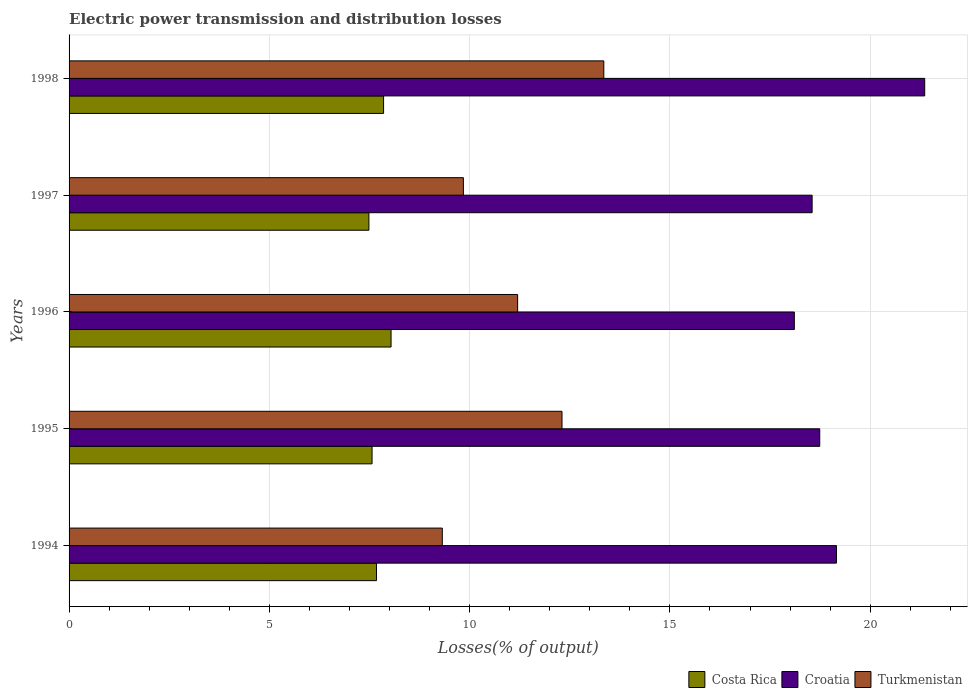How many different coloured bars are there?
Your response must be concise. 3. How many groups of bars are there?
Make the answer very short. 5. How many bars are there on the 4th tick from the top?
Provide a short and direct response. 3. What is the label of the 1st group of bars from the top?
Offer a terse response. 1998. In how many cases, is the number of bars for a given year not equal to the number of legend labels?
Your answer should be very brief. 0. What is the electric power transmission and distribution losses in Turkmenistan in 1995?
Your response must be concise. 12.31. Across all years, what is the maximum electric power transmission and distribution losses in Croatia?
Keep it short and to the point. 21.36. Across all years, what is the minimum electric power transmission and distribution losses in Croatia?
Provide a succinct answer. 18.11. What is the total electric power transmission and distribution losses in Croatia in the graph?
Give a very brief answer. 95.92. What is the difference between the electric power transmission and distribution losses in Croatia in 1994 and that in 1998?
Offer a very short reply. -2.2. What is the difference between the electric power transmission and distribution losses in Turkmenistan in 1994 and the electric power transmission and distribution losses in Croatia in 1996?
Give a very brief answer. -8.79. What is the average electric power transmission and distribution losses in Turkmenistan per year?
Your answer should be very brief. 11.2. In the year 1994, what is the difference between the electric power transmission and distribution losses in Turkmenistan and electric power transmission and distribution losses in Costa Rica?
Ensure brevity in your answer.  1.64. What is the ratio of the electric power transmission and distribution losses in Croatia in 1994 to that in 1997?
Keep it short and to the point. 1.03. What is the difference between the highest and the second highest electric power transmission and distribution losses in Croatia?
Give a very brief answer. 2.2. What is the difference between the highest and the lowest electric power transmission and distribution losses in Turkmenistan?
Your answer should be compact. 4.03. What does the 1st bar from the bottom in 1994 represents?
Your answer should be very brief. Costa Rica. How many bars are there?
Your answer should be compact. 15. Are all the bars in the graph horizontal?
Your response must be concise. Yes. Does the graph contain any zero values?
Provide a short and direct response. No. Does the graph contain grids?
Provide a short and direct response. Yes. Where does the legend appear in the graph?
Offer a terse response. Bottom right. What is the title of the graph?
Ensure brevity in your answer.  Electric power transmission and distribution losses. Does "Upper middle income" appear as one of the legend labels in the graph?
Ensure brevity in your answer.  No. What is the label or title of the X-axis?
Provide a succinct answer. Losses(% of output). What is the label or title of the Y-axis?
Give a very brief answer. Years. What is the Losses(% of output) in Costa Rica in 1994?
Keep it short and to the point. 7.68. What is the Losses(% of output) in Croatia in 1994?
Give a very brief answer. 19.16. What is the Losses(% of output) in Turkmenistan in 1994?
Offer a terse response. 9.32. What is the Losses(% of output) in Costa Rica in 1995?
Your response must be concise. 7.56. What is the Losses(% of output) of Croatia in 1995?
Offer a terse response. 18.74. What is the Losses(% of output) of Turkmenistan in 1995?
Ensure brevity in your answer.  12.31. What is the Losses(% of output) of Costa Rica in 1996?
Ensure brevity in your answer.  8.04. What is the Losses(% of output) of Croatia in 1996?
Ensure brevity in your answer.  18.11. What is the Losses(% of output) in Turkmenistan in 1996?
Offer a very short reply. 11.2. What is the Losses(% of output) of Costa Rica in 1997?
Give a very brief answer. 7.49. What is the Losses(% of output) of Croatia in 1997?
Make the answer very short. 18.55. What is the Losses(% of output) of Turkmenistan in 1997?
Offer a very short reply. 9.84. What is the Losses(% of output) of Costa Rica in 1998?
Ensure brevity in your answer.  7.85. What is the Losses(% of output) of Croatia in 1998?
Offer a terse response. 21.36. What is the Losses(% of output) of Turkmenistan in 1998?
Offer a very short reply. 13.35. Across all years, what is the maximum Losses(% of output) of Costa Rica?
Provide a short and direct response. 8.04. Across all years, what is the maximum Losses(% of output) of Croatia?
Make the answer very short. 21.36. Across all years, what is the maximum Losses(% of output) of Turkmenistan?
Keep it short and to the point. 13.35. Across all years, what is the minimum Losses(% of output) in Costa Rica?
Your answer should be very brief. 7.49. Across all years, what is the minimum Losses(% of output) in Croatia?
Your answer should be very brief. 18.11. Across all years, what is the minimum Losses(% of output) in Turkmenistan?
Offer a very short reply. 9.32. What is the total Losses(% of output) in Costa Rica in the graph?
Offer a terse response. 38.61. What is the total Losses(% of output) in Croatia in the graph?
Give a very brief answer. 95.92. What is the total Losses(% of output) in Turkmenistan in the graph?
Keep it short and to the point. 56.02. What is the difference between the Losses(% of output) in Costa Rica in 1994 and that in 1995?
Offer a very short reply. 0.11. What is the difference between the Losses(% of output) in Croatia in 1994 and that in 1995?
Make the answer very short. 0.42. What is the difference between the Losses(% of output) in Turkmenistan in 1994 and that in 1995?
Offer a very short reply. -2.99. What is the difference between the Losses(% of output) of Costa Rica in 1994 and that in 1996?
Your response must be concise. -0.36. What is the difference between the Losses(% of output) of Croatia in 1994 and that in 1996?
Provide a short and direct response. 1.05. What is the difference between the Losses(% of output) of Turkmenistan in 1994 and that in 1996?
Offer a very short reply. -1.88. What is the difference between the Losses(% of output) in Costa Rica in 1994 and that in 1997?
Ensure brevity in your answer.  0.19. What is the difference between the Losses(% of output) in Croatia in 1994 and that in 1997?
Offer a terse response. 0.61. What is the difference between the Losses(% of output) of Turkmenistan in 1994 and that in 1997?
Ensure brevity in your answer.  -0.53. What is the difference between the Losses(% of output) in Costa Rica in 1994 and that in 1998?
Provide a succinct answer. -0.18. What is the difference between the Losses(% of output) in Croatia in 1994 and that in 1998?
Keep it short and to the point. -2.2. What is the difference between the Losses(% of output) in Turkmenistan in 1994 and that in 1998?
Provide a succinct answer. -4.03. What is the difference between the Losses(% of output) of Costa Rica in 1995 and that in 1996?
Give a very brief answer. -0.47. What is the difference between the Losses(% of output) in Croatia in 1995 and that in 1996?
Make the answer very short. 0.63. What is the difference between the Losses(% of output) in Turkmenistan in 1995 and that in 1996?
Keep it short and to the point. 1.11. What is the difference between the Losses(% of output) of Costa Rica in 1995 and that in 1997?
Provide a short and direct response. 0.08. What is the difference between the Losses(% of output) in Croatia in 1995 and that in 1997?
Your response must be concise. 0.19. What is the difference between the Losses(% of output) in Turkmenistan in 1995 and that in 1997?
Your answer should be compact. 2.46. What is the difference between the Losses(% of output) in Costa Rica in 1995 and that in 1998?
Provide a short and direct response. -0.29. What is the difference between the Losses(% of output) of Croatia in 1995 and that in 1998?
Offer a very short reply. -2.62. What is the difference between the Losses(% of output) in Turkmenistan in 1995 and that in 1998?
Provide a succinct answer. -1.04. What is the difference between the Losses(% of output) of Costa Rica in 1996 and that in 1997?
Make the answer very short. 0.55. What is the difference between the Losses(% of output) in Croatia in 1996 and that in 1997?
Your response must be concise. -0.44. What is the difference between the Losses(% of output) in Turkmenistan in 1996 and that in 1997?
Make the answer very short. 1.35. What is the difference between the Losses(% of output) in Costa Rica in 1996 and that in 1998?
Offer a terse response. 0.19. What is the difference between the Losses(% of output) of Croatia in 1996 and that in 1998?
Offer a terse response. -3.26. What is the difference between the Losses(% of output) in Turkmenistan in 1996 and that in 1998?
Ensure brevity in your answer.  -2.15. What is the difference between the Losses(% of output) of Costa Rica in 1997 and that in 1998?
Your answer should be very brief. -0.37. What is the difference between the Losses(% of output) in Croatia in 1997 and that in 1998?
Your answer should be very brief. -2.81. What is the difference between the Losses(% of output) of Turkmenistan in 1997 and that in 1998?
Offer a very short reply. -3.51. What is the difference between the Losses(% of output) of Costa Rica in 1994 and the Losses(% of output) of Croatia in 1995?
Your response must be concise. -11.06. What is the difference between the Losses(% of output) in Costa Rica in 1994 and the Losses(% of output) in Turkmenistan in 1995?
Your response must be concise. -4.63. What is the difference between the Losses(% of output) in Croatia in 1994 and the Losses(% of output) in Turkmenistan in 1995?
Offer a terse response. 6.85. What is the difference between the Losses(% of output) of Costa Rica in 1994 and the Losses(% of output) of Croatia in 1996?
Offer a terse response. -10.43. What is the difference between the Losses(% of output) in Costa Rica in 1994 and the Losses(% of output) in Turkmenistan in 1996?
Your answer should be compact. -3.52. What is the difference between the Losses(% of output) of Croatia in 1994 and the Losses(% of output) of Turkmenistan in 1996?
Your answer should be very brief. 7.96. What is the difference between the Losses(% of output) of Costa Rica in 1994 and the Losses(% of output) of Croatia in 1997?
Ensure brevity in your answer.  -10.88. What is the difference between the Losses(% of output) in Costa Rica in 1994 and the Losses(% of output) in Turkmenistan in 1997?
Your answer should be compact. -2.17. What is the difference between the Losses(% of output) in Croatia in 1994 and the Losses(% of output) in Turkmenistan in 1997?
Ensure brevity in your answer.  9.31. What is the difference between the Losses(% of output) in Costa Rica in 1994 and the Losses(% of output) in Croatia in 1998?
Keep it short and to the point. -13.69. What is the difference between the Losses(% of output) of Costa Rica in 1994 and the Losses(% of output) of Turkmenistan in 1998?
Give a very brief answer. -5.67. What is the difference between the Losses(% of output) in Croatia in 1994 and the Losses(% of output) in Turkmenistan in 1998?
Your answer should be compact. 5.81. What is the difference between the Losses(% of output) in Costa Rica in 1995 and the Losses(% of output) in Croatia in 1996?
Your answer should be compact. -10.54. What is the difference between the Losses(% of output) in Costa Rica in 1995 and the Losses(% of output) in Turkmenistan in 1996?
Provide a succinct answer. -3.63. What is the difference between the Losses(% of output) in Croatia in 1995 and the Losses(% of output) in Turkmenistan in 1996?
Offer a terse response. 7.54. What is the difference between the Losses(% of output) in Costa Rica in 1995 and the Losses(% of output) in Croatia in 1997?
Ensure brevity in your answer.  -10.99. What is the difference between the Losses(% of output) in Costa Rica in 1995 and the Losses(% of output) in Turkmenistan in 1997?
Your response must be concise. -2.28. What is the difference between the Losses(% of output) of Croatia in 1995 and the Losses(% of output) of Turkmenistan in 1997?
Offer a very short reply. 8.9. What is the difference between the Losses(% of output) in Costa Rica in 1995 and the Losses(% of output) in Croatia in 1998?
Make the answer very short. -13.8. What is the difference between the Losses(% of output) of Costa Rica in 1995 and the Losses(% of output) of Turkmenistan in 1998?
Your response must be concise. -5.79. What is the difference between the Losses(% of output) in Croatia in 1995 and the Losses(% of output) in Turkmenistan in 1998?
Your answer should be compact. 5.39. What is the difference between the Losses(% of output) of Costa Rica in 1996 and the Losses(% of output) of Croatia in 1997?
Your answer should be very brief. -10.51. What is the difference between the Losses(% of output) in Costa Rica in 1996 and the Losses(% of output) in Turkmenistan in 1997?
Your response must be concise. -1.81. What is the difference between the Losses(% of output) of Croatia in 1996 and the Losses(% of output) of Turkmenistan in 1997?
Keep it short and to the point. 8.26. What is the difference between the Losses(% of output) of Costa Rica in 1996 and the Losses(% of output) of Croatia in 1998?
Give a very brief answer. -13.32. What is the difference between the Losses(% of output) of Costa Rica in 1996 and the Losses(% of output) of Turkmenistan in 1998?
Offer a very short reply. -5.31. What is the difference between the Losses(% of output) of Croatia in 1996 and the Losses(% of output) of Turkmenistan in 1998?
Ensure brevity in your answer.  4.76. What is the difference between the Losses(% of output) in Costa Rica in 1997 and the Losses(% of output) in Croatia in 1998?
Your response must be concise. -13.88. What is the difference between the Losses(% of output) in Costa Rica in 1997 and the Losses(% of output) in Turkmenistan in 1998?
Make the answer very short. -5.86. What is the difference between the Losses(% of output) of Croatia in 1997 and the Losses(% of output) of Turkmenistan in 1998?
Give a very brief answer. 5.2. What is the average Losses(% of output) of Costa Rica per year?
Ensure brevity in your answer.  7.72. What is the average Losses(% of output) in Croatia per year?
Your response must be concise. 19.18. What is the average Losses(% of output) of Turkmenistan per year?
Your answer should be very brief. 11.2. In the year 1994, what is the difference between the Losses(% of output) of Costa Rica and Losses(% of output) of Croatia?
Your response must be concise. -11.48. In the year 1994, what is the difference between the Losses(% of output) in Costa Rica and Losses(% of output) in Turkmenistan?
Your response must be concise. -1.64. In the year 1994, what is the difference between the Losses(% of output) in Croatia and Losses(% of output) in Turkmenistan?
Provide a succinct answer. 9.84. In the year 1995, what is the difference between the Losses(% of output) in Costa Rica and Losses(% of output) in Croatia?
Offer a terse response. -11.18. In the year 1995, what is the difference between the Losses(% of output) of Costa Rica and Losses(% of output) of Turkmenistan?
Keep it short and to the point. -4.74. In the year 1995, what is the difference between the Losses(% of output) in Croatia and Losses(% of output) in Turkmenistan?
Your answer should be compact. 6.43. In the year 1996, what is the difference between the Losses(% of output) of Costa Rica and Losses(% of output) of Croatia?
Keep it short and to the point. -10.07. In the year 1996, what is the difference between the Losses(% of output) in Costa Rica and Losses(% of output) in Turkmenistan?
Offer a very short reply. -3.16. In the year 1996, what is the difference between the Losses(% of output) of Croatia and Losses(% of output) of Turkmenistan?
Provide a succinct answer. 6.91. In the year 1997, what is the difference between the Losses(% of output) in Costa Rica and Losses(% of output) in Croatia?
Offer a very short reply. -11.06. In the year 1997, what is the difference between the Losses(% of output) of Costa Rica and Losses(% of output) of Turkmenistan?
Your answer should be very brief. -2.36. In the year 1997, what is the difference between the Losses(% of output) of Croatia and Losses(% of output) of Turkmenistan?
Make the answer very short. 8.71. In the year 1998, what is the difference between the Losses(% of output) of Costa Rica and Losses(% of output) of Croatia?
Keep it short and to the point. -13.51. In the year 1998, what is the difference between the Losses(% of output) in Costa Rica and Losses(% of output) in Turkmenistan?
Your answer should be compact. -5.5. In the year 1998, what is the difference between the Losses(% of output) in Croatia and Losses(% of output) in Turkmenistan?
Offer a very short reply. 8.01. What is the ratio of the Losses(% of output) of Costa Rica in 1994 to that in 1995?
Keep it short and to the point. 1.01. What is the ratio of the Losses(% of output) in Croatia in 1994 to that in 1995?
Give a very brief answer. 1.02. What is the ratio of the Losses(% of output) of Turkmenistan in 1994 to that in 1995?
Make the answer very short. 0.76. What is the ratio of the Losses(% of output) of Costa Rica in 1994 to that in 1996?
Your answer should be compact. 0.95. What is the ratio of the Losses(% of output) in Croatia in 1994 to that in 1996?
Your answer should be compact. 1.06. What is the ratio of the Losses(% of output) of Turkmenistan in 1994 to that in 1996?
Offer a very short reply. 0.83. What is the ratio of the Losses(% of output) of Costa Rica in 1994 to that in 1997?
Offer a terse response. 1.03. What is the ratio of the Losses(% of output) of Croatia in 1994 to that in 1997?
Your response must be concise. 1.03. What is the ratio of the Losses(% of output) of Turkmenistan in 1994 to that in 1997?
Offer a very short reply. 0.95. What is the ratio of the Losses(% of output) of Costa Rica in 1994 to that in 1998?
Ensure brevity in your answer.  0.98. What is the ratio of the Losses(% of output) in Croatia in 1994 to that in 1998?
Make the answer very short. 0.9. What is the ratio of the Losses(% of output) in Turkmenistan in 1994 to that in 1998?
Your response must be concise. 0.7. What is the ratio of the Losses(% of output) in Costa Rica in 1995 to that in 1996?
Keep it short and to the point. 0.94. What is the ratio of the Losses(% of output) in Croatia in 1995 to that in 1996?
Offer a very short reply. 1.03. What is the ratio of the Losses(% of output) in Turkmenistan in 1995 to that in 1996?
Make the answer very short. 1.1. What is the ratio of the Losses(% of output) in Costa Rica in 1995 to that in 1997?
Ensure brevity in your answer.  1.01. What is the ratio of the Losses(% of output) of Croatia in 1995 to that in 1997?
Give a very brief answer. 1.01. What is the ratio of the Losses(% of output) of Turkmenistan in 1995 to that in 1997?
Your answer should be compact. 1.25. What is the ratio of the Losses(% of output) in Costa Rica in 1995 to that in 1998?
Provide a short and direct response. 0.96. What is the ratio of the Losses(% of output) in Croatia in 1995 to that in 1998?
Offer a terse response. 0.88. What is the ratio of the Losses(% of output) of Turkmenistan in 1995 to that in 1998?
Keep it short and to the point. 0.92. What is the ratio of the Losses(% of output) of Costa Rica in 1996 to that in 1997?
Make the answer very short. 1.07. What is the ratio of the Losses(% of output) in Croatia in 1996 to that in 1997?
Ensure brevity in your answer.  0.98. What is the ratio of the Losses(% of output) of Turkmenistan in 1996 to that in 1997?
Your answer should be very brief. 1.14. What is the ratio of the Losses(% of output) in Costa Rica in 1996 to that in 1998?
Provide a short and direct response. 1.02. What is the ratio of the Losses(% of output) of Croatia in 1996 to that in 1998?
Offer a very short reply. 0.85. What is the ratio of the Losses(% of output) in Turkmenistan in 1996 to that in 1998?
Offer a terse response. 0.84. What is the ratio of the Losses(% of output) of Costa Rica in 1997 to that in 1998?
Make the answer very short. 0.95. What is the ratio of the Losses(% of output) in Croatia in 1997 to that in 1998?
Your answer should be compact. 0.87. What is the ratio of the Losses(% of output) in Turkmenistan in 1997 to that in 1998?
Offer a terse response. 0.74. What is the difference between the highest and the second highest Losses(% of output) in Costa Rica?
Give a very brief answer. 0.19. What is the difference between the highest and the second highest Losses(% of output) in Croatia?
Your answer should be very brief. 2.2. What is the difference between the highest and the second highest Losses(% of output) of Turkmenistan?
Your response must be concise. 1.04. What is the difference between the highest and the lowest Losses(% of output) in Costa Rica?
Keep it short and to the point. 0.55. What is the difference between the highest and the lowest Losses(% of output) in Croatia?
Your answer should be compact. 3.26. What is the difference between the highest and the lowest Losses(% of output) of Turkmenistan?
Offer a terse response. 4.03. 